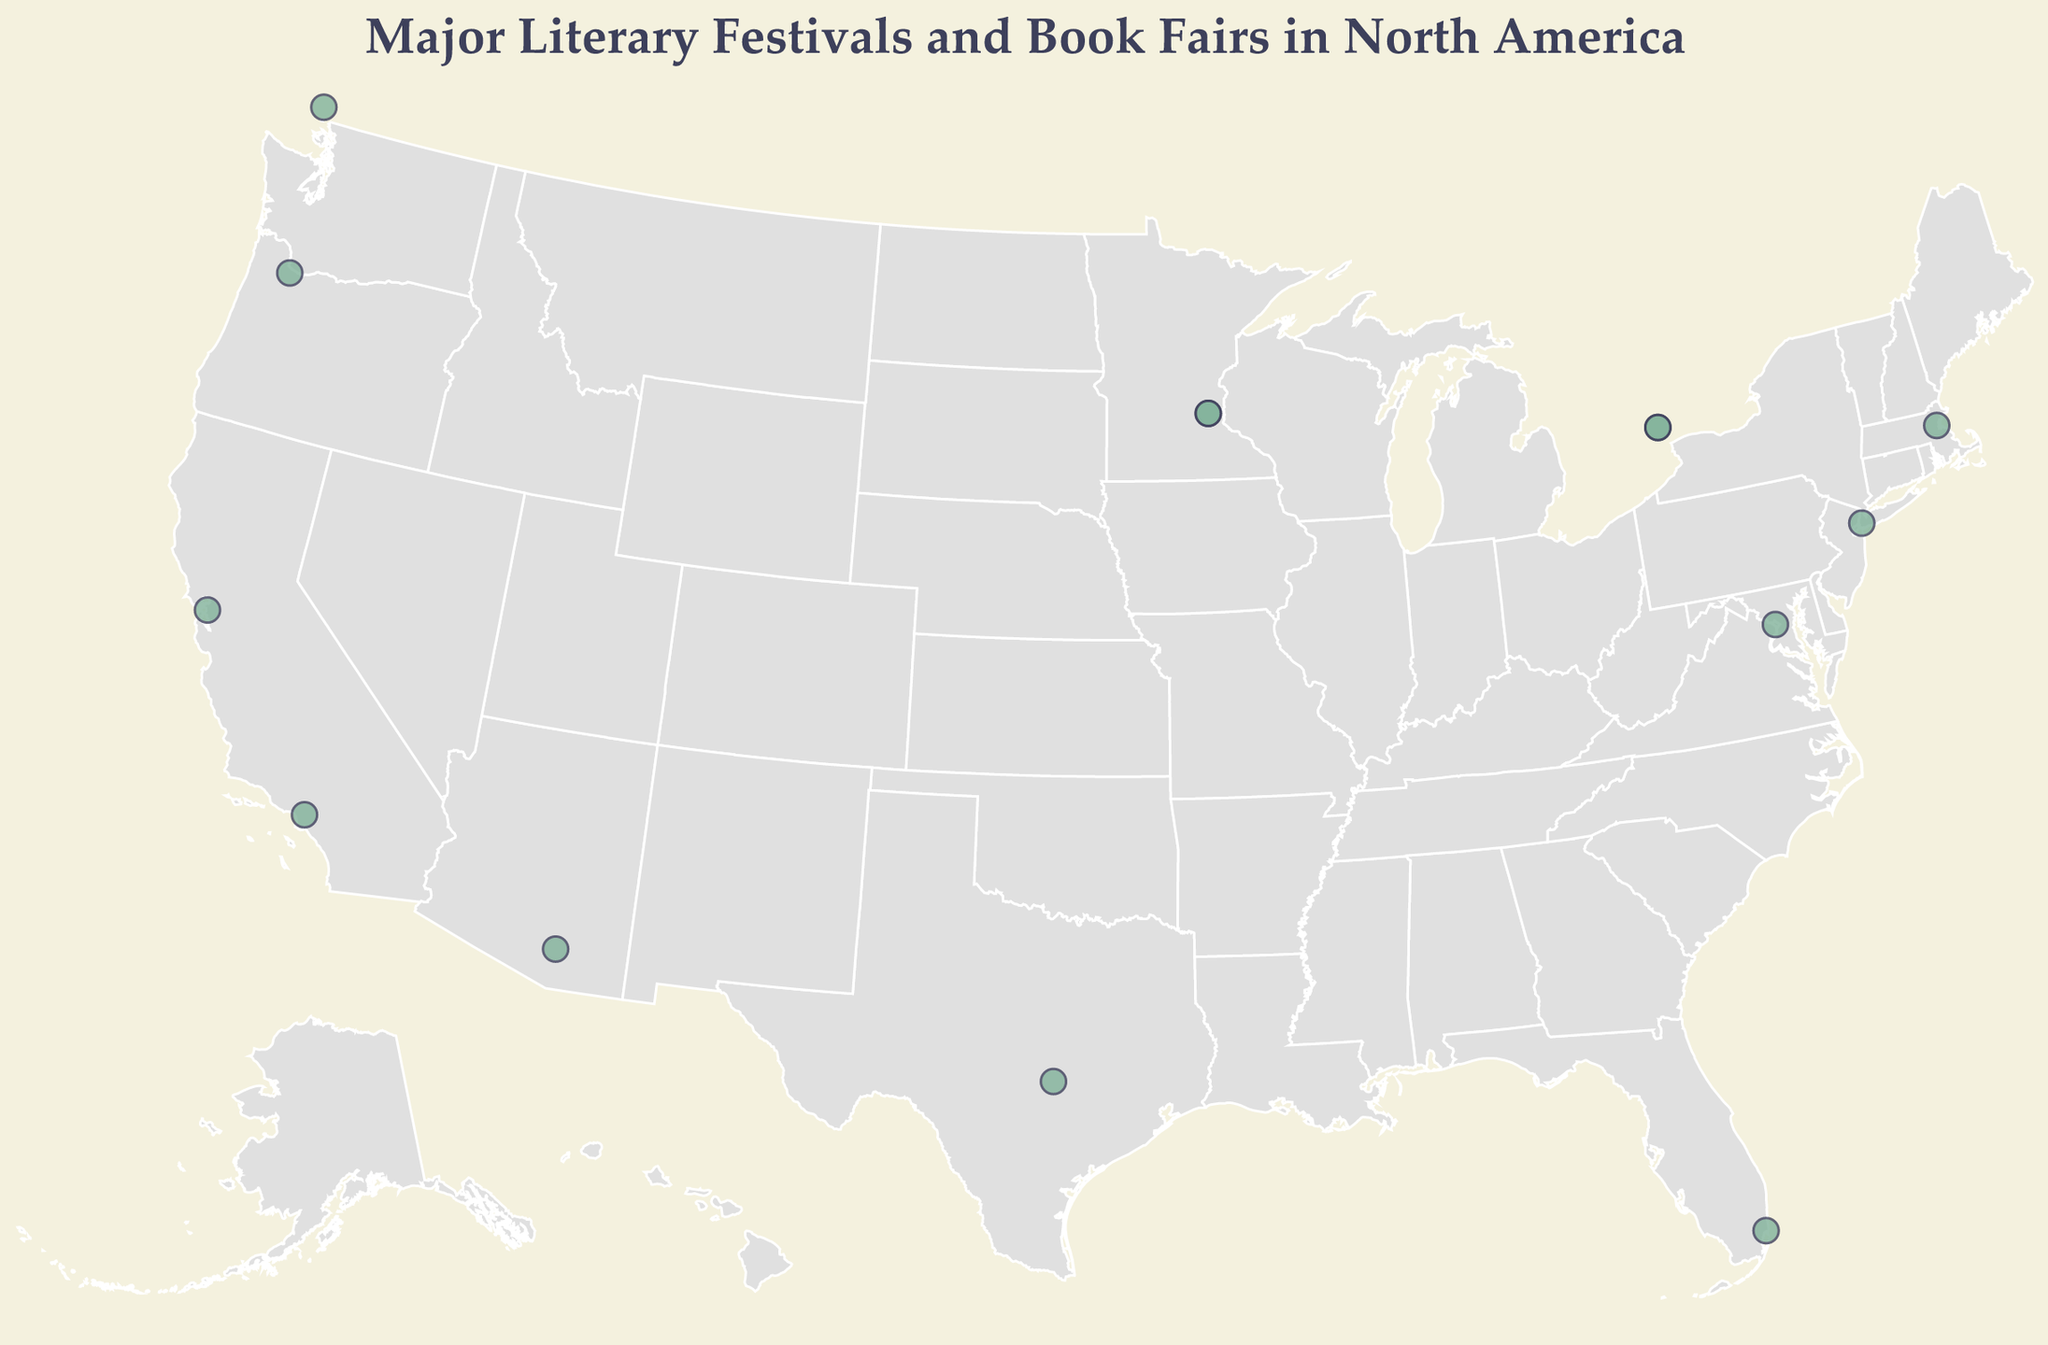What's the title of the plot? The title is located at the top of the figure and reads "Major Literary Festivals and Book Fairs in North America".
Answer: Major Literary Festivals and Book Fairs in North America What color are the circles representing each event? The circles are shown in the figure with a greenish hue and slight opacity.
Answer: Greenish hue How many literary festivals are displayed in the figure? By counting the number of circles representing each event, we can determine the total number of festivals.
Answer: 14 Which city hosts more than one literary festival? By examining the circles and their associated tooltips, we can see that Toronto and Minneapolis each have multiple circles indicating multiple events.
Answer: Toronto and Minneapolis What is the northernmost literary festival on the figure? The northernmost literary festival can be identified by locating the circle furthest north (highest latitude), which is the Vancouver Writers Fest.
Answer: Vancouver Writers Fest How many festivals are held in Canada? We can identify festivals held in Canada by their tooltip information mentioning cities in Canada, totaling three festivals (Toronto, Vancouver, Toronto again).
Answer: 3 Which literary festival is closest to the geographic center of the United States? By analyzing the geographical locations and roughly estimating the central position of the USA, the Heartland Fall Forum and Wordplay Festival in Minneapolis are closest.
Answer: Heartland Fall Forum and Wordplay Festival Which two festivals are located in California? Observing the circles in California and their tooltips, the Los Angeles Times Festival of Books and the Bay Area Book Festival are located in California.
Answer: Los Angeles Times Festival of Books and Bay Area Book Festival Compare the latitude of the Texas Book Festival and the Miami Book Fair. Which one is further south? By comparing their latitudes, Texas Book Festival (30.2672) and Miami Book Fair (25.7617), Miami Book Fair is further south.
Answer: Miami Book Fair What are the easternmost and westernmost festivals shown on the plot? To find the easternmost and westernmost festivals, we look at the longitudes of the circles, where Brooklyn Book Festival in New York is the easternmost, and Vancouver Writers Fest in British Columbia is the westernmost.
Answer: Brooklyn Book Festival (easternmost) and Vancouver Writers Fest (westernmost) 